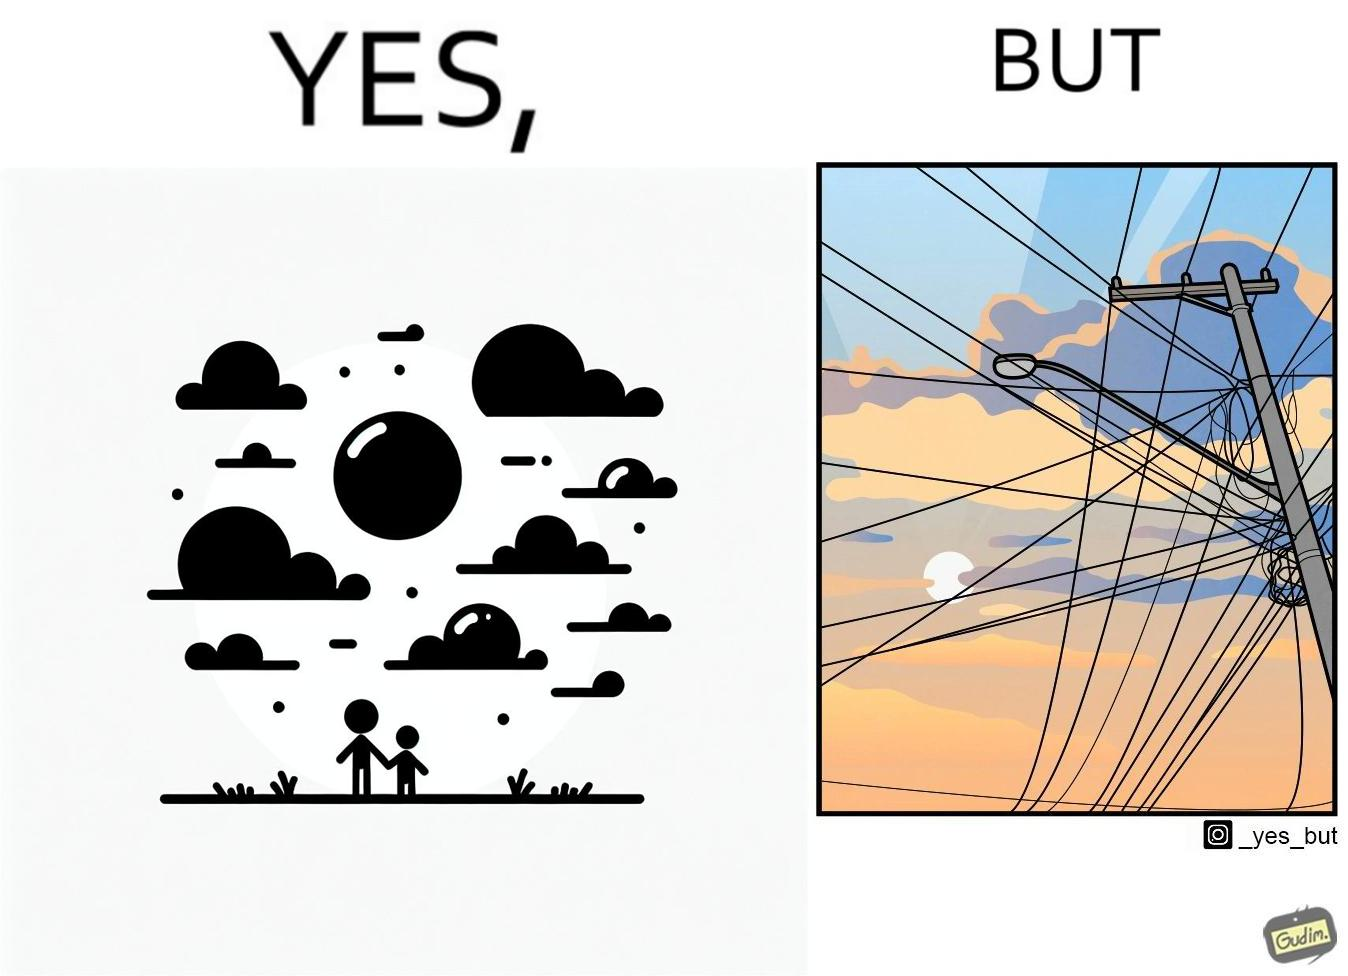Provide a description of this image. The image is ironic, because in the first image clear sky is visible but in the second image the same view is getting blocked due to the electricity pole 